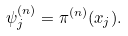Convert formula to latex. <formula><loc_0><loc_0><loc_500><loc_500>\psi _ { j } ^ { ( n ) } = \pi ^ { ( n ) } ( x _ { j } ) .</formula> 